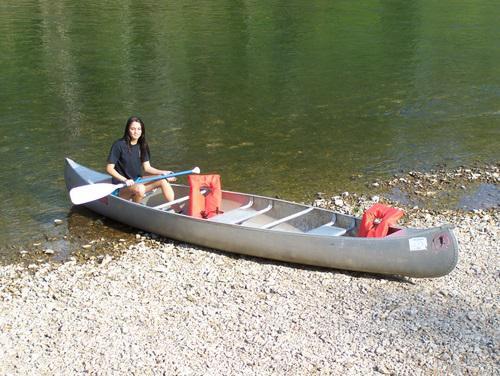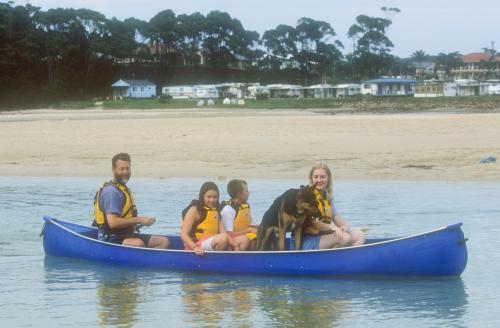The first image is the image on the left, the second image is the image on the right. Evaluate the accuracy of this statement regarding the images: "There is at most 1 dog in a canoe.". Is it true? Answer yes or no. Yes. The first image is the image on the left, the second image is the image on the right. Analyze the images presented: Is the assertion "None of the boats are blue." valid? Answer yes or no. No. 